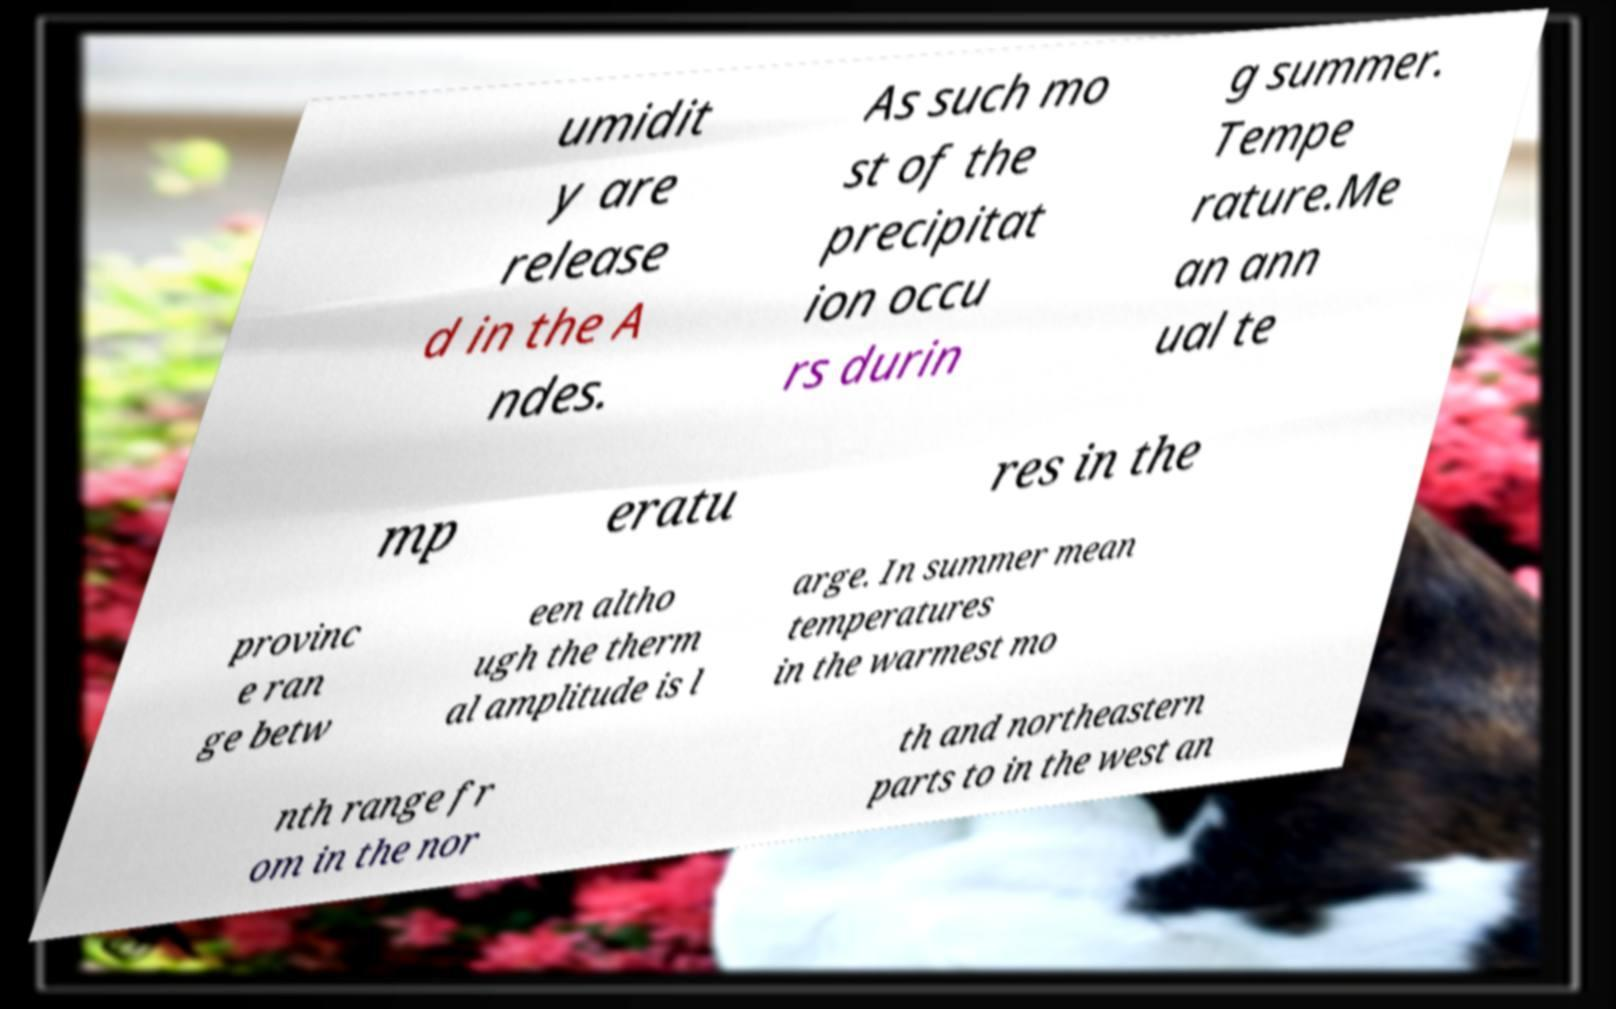What messages or text are displayed in this image? I need them in a readable, typed format. umidit y are release d in the A ndes. As such mo st of the precipitat ion occu rs durin g summer. Tempe rature.Me an ann ual te mp eratu res in the provinc e ran ge betw een altho ugh the therm al amplitude is l arge. In summer mean temperatures in the warmest mo nth range fr om in the nor th and northeastern parts to in the west an 